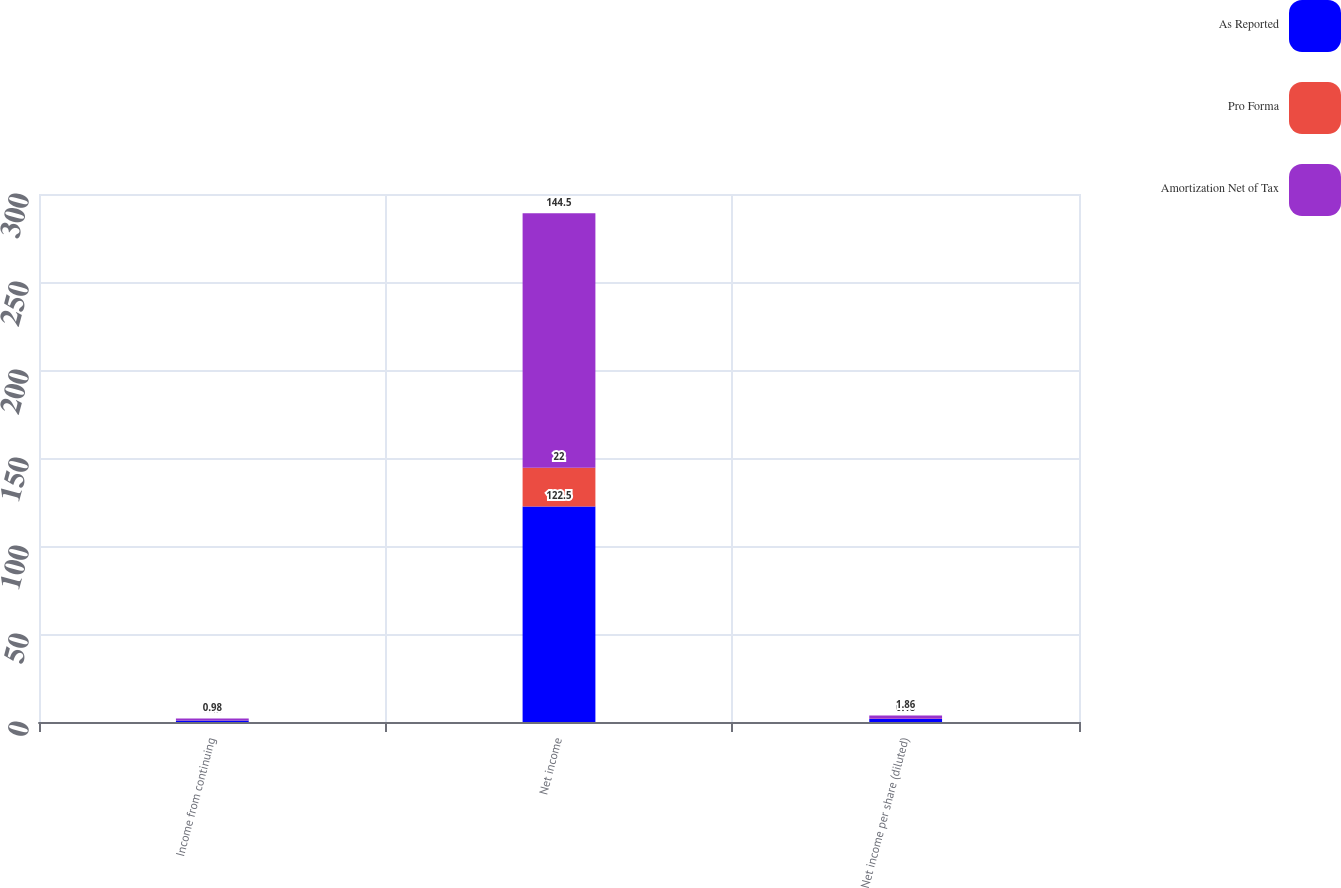<chart> <loc_0><loc_0><loc_500><loc_500><stacked_bar_chart><ecel><fcel>Income from continuing<fcel>Net income<fcel>Net income per share (diluted)<nl><fcel>As Reported<fcel>0.84<fcel>122.5<fcel>1.68<nl><fcel>Pro Forma<fcel>0.13<fcel>22<fcel>0.18<nl><fcel>Amortization Net of Tax<fcel>0.98<fcel>144.5<fcel>1.86<nl></chart> 